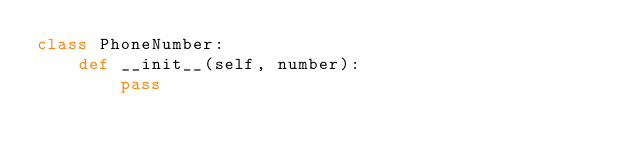<code> <loc_0><loc_0><loc_500><loc_500><_Python_>class PhoneNumber:
    def __init__(self, number):
        pass
</code> 